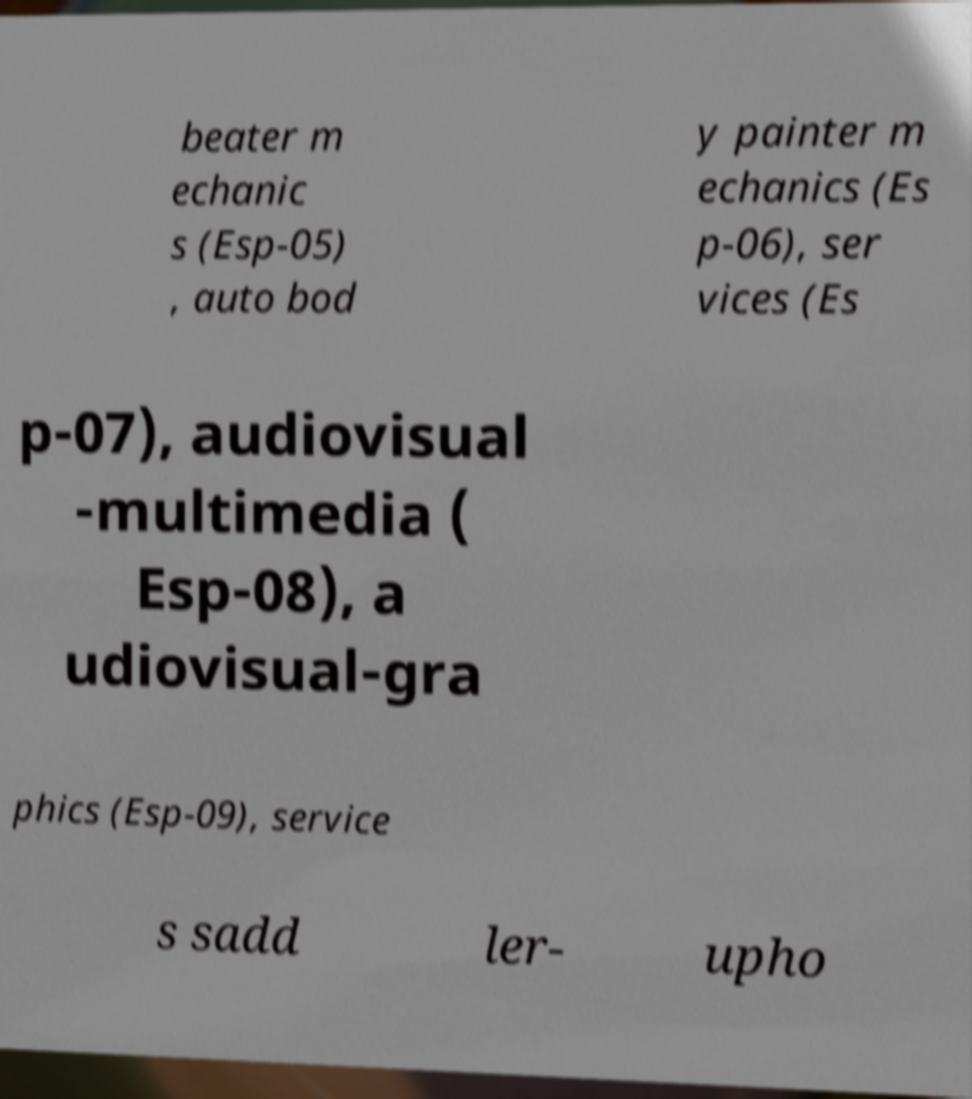Can you accurately transcribe the text from the provided image for me? beater m echanic s (Esp-05) , auto bod y painter m echanics (Es p-06), ser vices (Es p-07), audiovisual -multimedia ( Esp-08), a udiovisual-gra phics (Esp-09), service s sadd ler- upho 